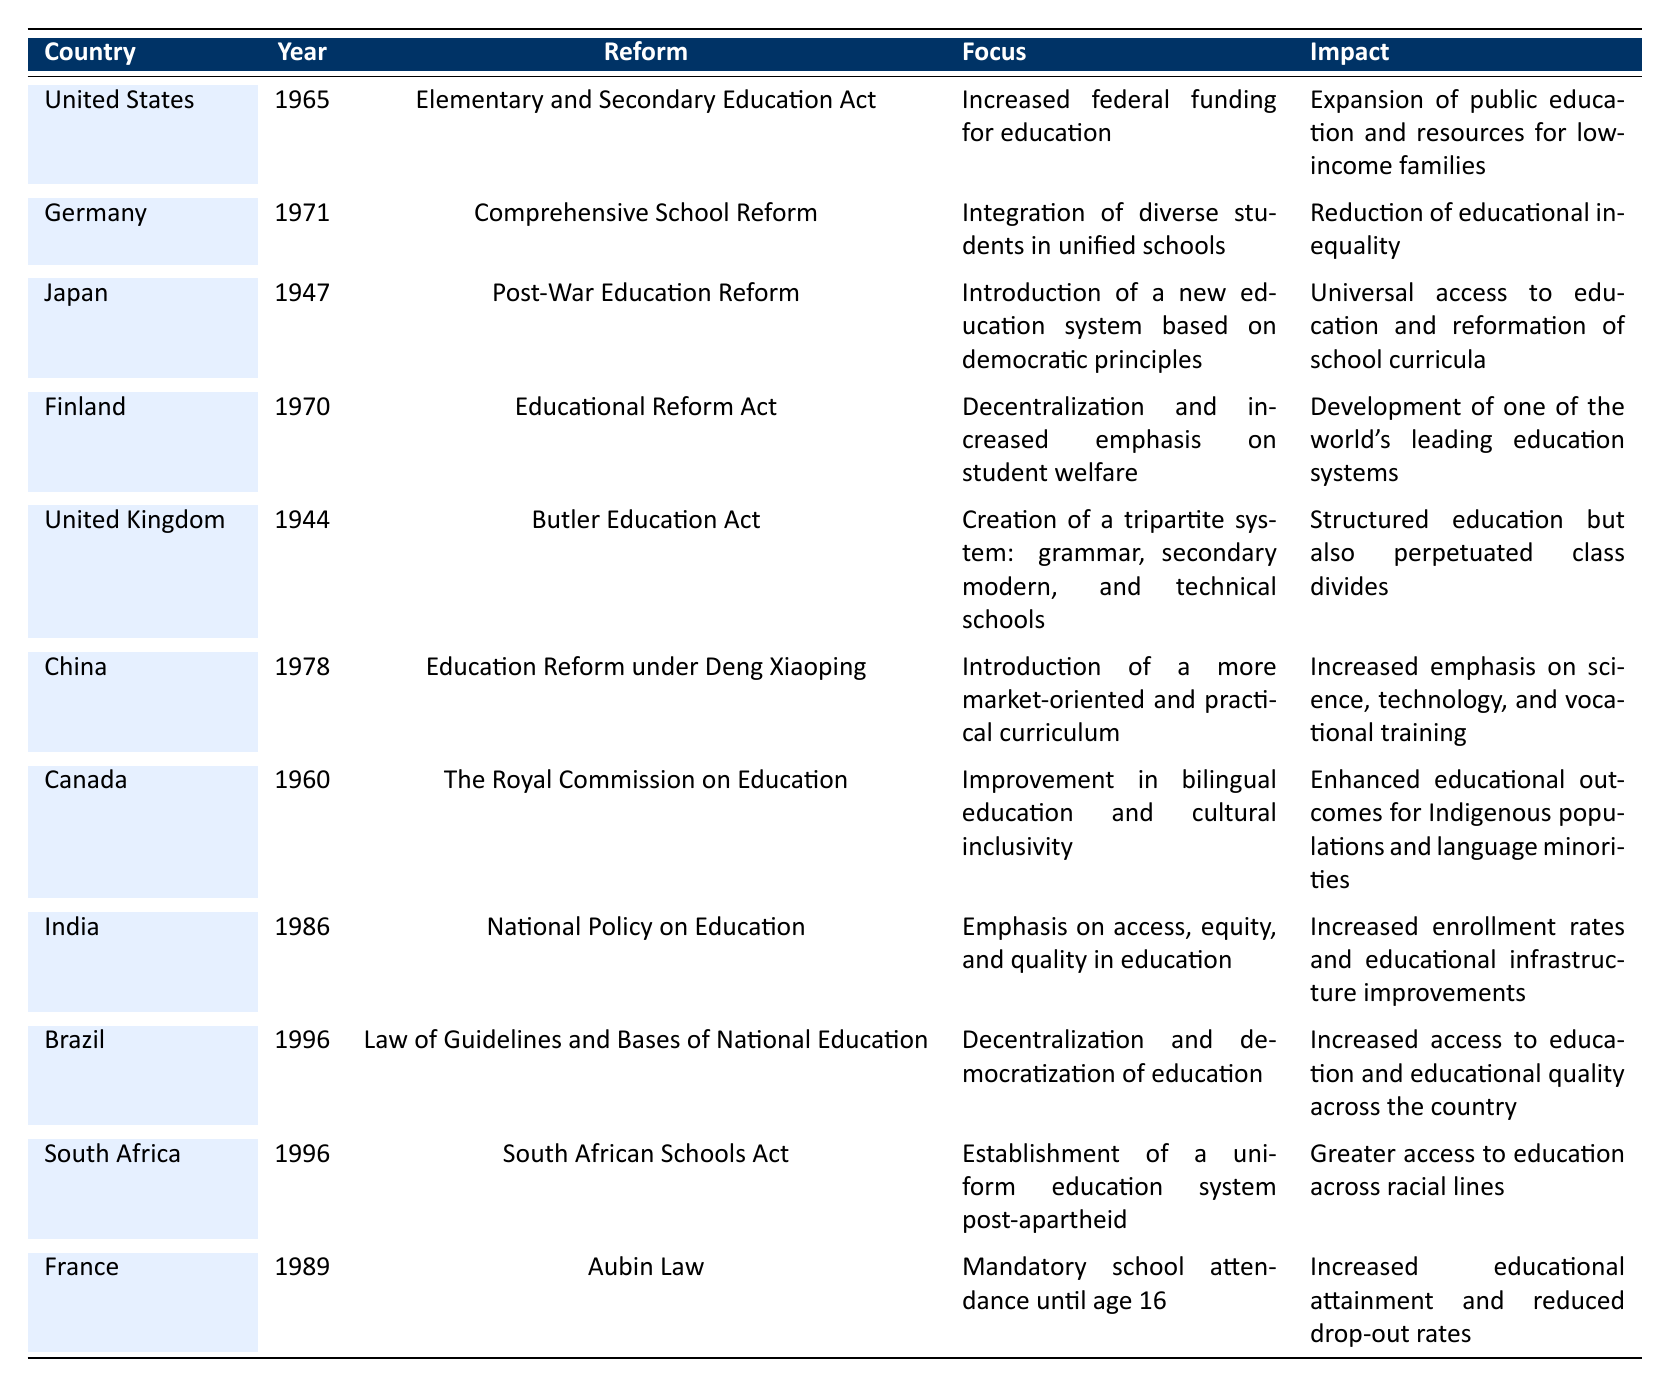What educational reform occurred in the United States in 1965? The table shows that the educational reform in the United States in 1965 was the "Elementary and Secondary Education Act."
Answer: Elementary and Secondary Education Act What was the focus of the Comprehensive School Reform in Germany? According to the table, the focus of the Comprehensive School Reform in Germany in 1971 was on the "Integration of diverse students in unified schools."
Answer: Integration of diverse students in unified schools Did Japan's Post-War Education Reform in 1947 emphasize democratic principles? The table indicates that Japan's Post-War Education Reform's focus was indeed on introducing a new education system based on democratic principles, so the statement is true.
Answer: Yes Which two countries implemented educational reforms in 1996? By examining the table, we see that both Brazil and South Africa enacted educational reforms in 1996.
Answer: Brazil and South Africa What was the impact of the Aldrin Law in France, enacted in 1989? The table cites that the Aubin Law in France, enacted in 1989, led to "Increased educational attainment and reduced drop-out rates."
Answer: Increased educational attainment and reduced drop-out rates Which reform aimed at increased student welfare in Finland was enacted in 1970? The table specifies that Finland's "Educational Reform Act," enacted in 1970, focused on decentralization and increased emphasis on student welfare.
Answer: Educational Reform Act What year did China implement educational reform under Deng Xiaoping? From the table, it is clear that the year when China implemented the education reform under Deng Xiaoping was 1978.
Answer: 1978 Which country's reform was specifically aimed at improving educational outcomes for Indigenous populations? The table states that Canada’s reform, "The Royal Commission on Education" in 1960, aimed at improving educational outcomes for Indigenous populations and language minorities.
Answer: Canada How many reforms focused on increased access and equity in education across the table's data? Reviewing the data, both India’s National Policy on Education and Brazil’s Law of Guidelines and Bases of National Education focused on access and equity, making a total of 2 reforms.
Answer: 2 Was the Butler Education Act in the United Kingdom associated with a tripartite system? The table confirms that the Butler Education Act instituted a tripartite system of education, so this statement is true.
Answer: Yes What were the impacts of the South African Schools Act in 1996? According to the table, the South African Schools Act aimed to establish a uniform education system post-apartheid, resulting in greater access to education across racial lines.
Answer: Greater access to education across racial lines Which educational reform occurred before 1950 and emphasized democratic principles? The table clearly indicates that Japan’s Post-War Education Reform, enacted in 1947, emphasized democratic principles, making it the correct answer.
Answer: Post-War Education Reform What is the common theme among all reforms listed in the table? The common theme is that all reforms aimed at improving educational access, equity, and quality in various ways, as described in their focuses and impacts.
Answer: Improving educational access, equity, and quality How did the educational reforms in both Canada and India cater to cultural inclusivity? The table shows that Canada’s reform focused on bilingual education and cultural inclusivity, while India’s reform focused on access and equity in education. Together, they reflect a trend towards inclusivity in education policies.
Answer: Reflecting a trend towards inclusivity in education policies What major change did the 1944 Butler Education Act bring to the UK's education system? The table reveals that it created a tripartite system, introducing grammar, secondary modern, and technical schools, which was a structured approach to education.
Answer: Created a tripartite system 